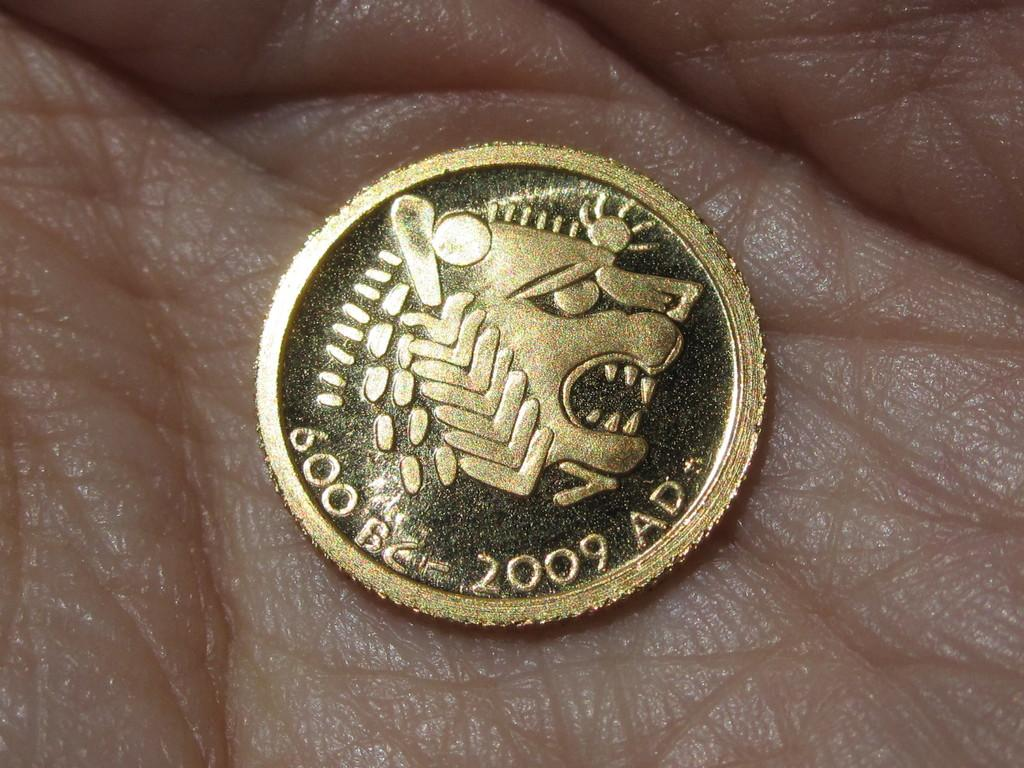<image>
Summarize the visual content of the image. A coin in someone's palm commemorates 2,609 years. 